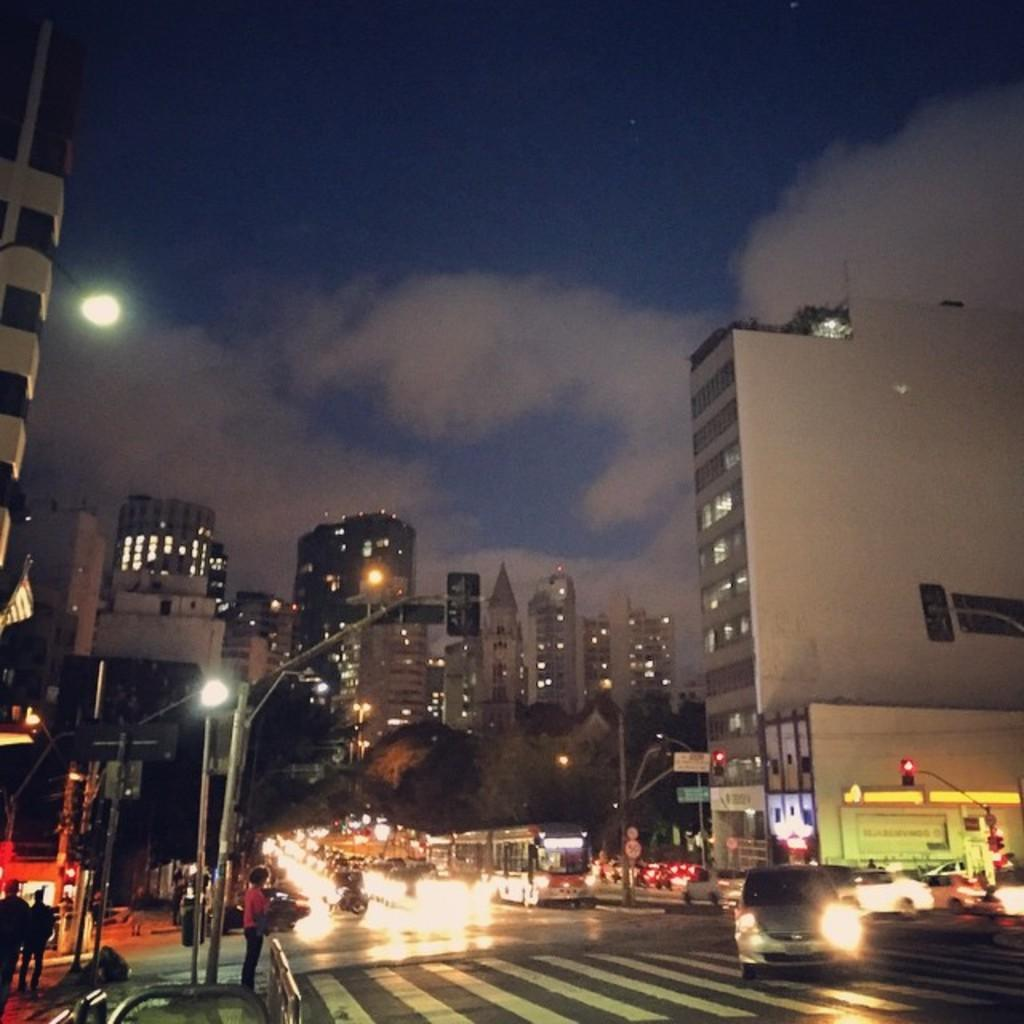What type of structures can be seen in the image? There are buildings in the image. What other objects are present in the image? There are poles, trees, boards, lights, and people visible in the image. What is happening on the road in the image? There are vehicles on the road in the image. What can be seen in the background of the image? There is sky visible in the background of the image, with clouds present. Can you tell me how many clover leaves are on the ground in the image? There is no clover present in the image, so it is not possible to determine the number of clover leaves. What is the mother of the people in the image doing? There is no indication of a mother or any specific actions being performed by the people in the image. Are there any horses visible in the image? There are no horses present in the image. 